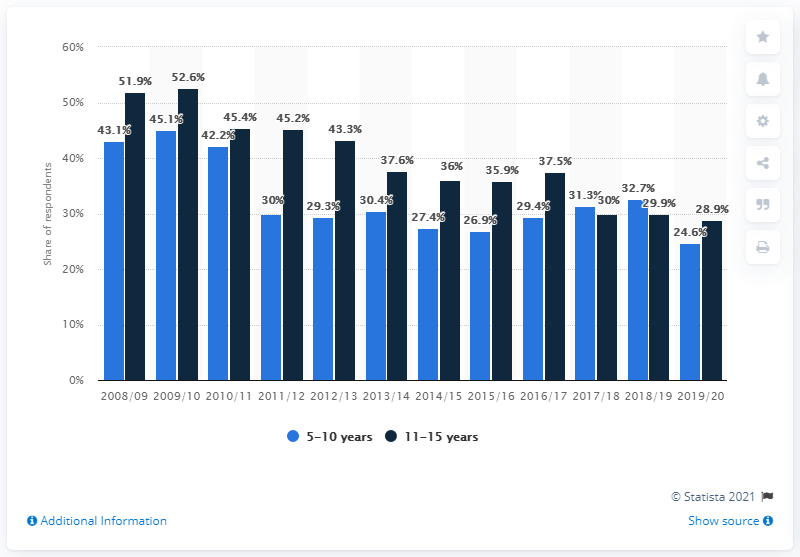Point out several critical features in this image. In the 2009/10 school year, it was found that 52.6% of children participated in dance activities. In the 2019/2020 academic year, it was reported that 28.9% of 11-15 year olds participated in dance activities. According to the data, approximately 24.6% of 5-10 year olds participated in dance activities this year. 